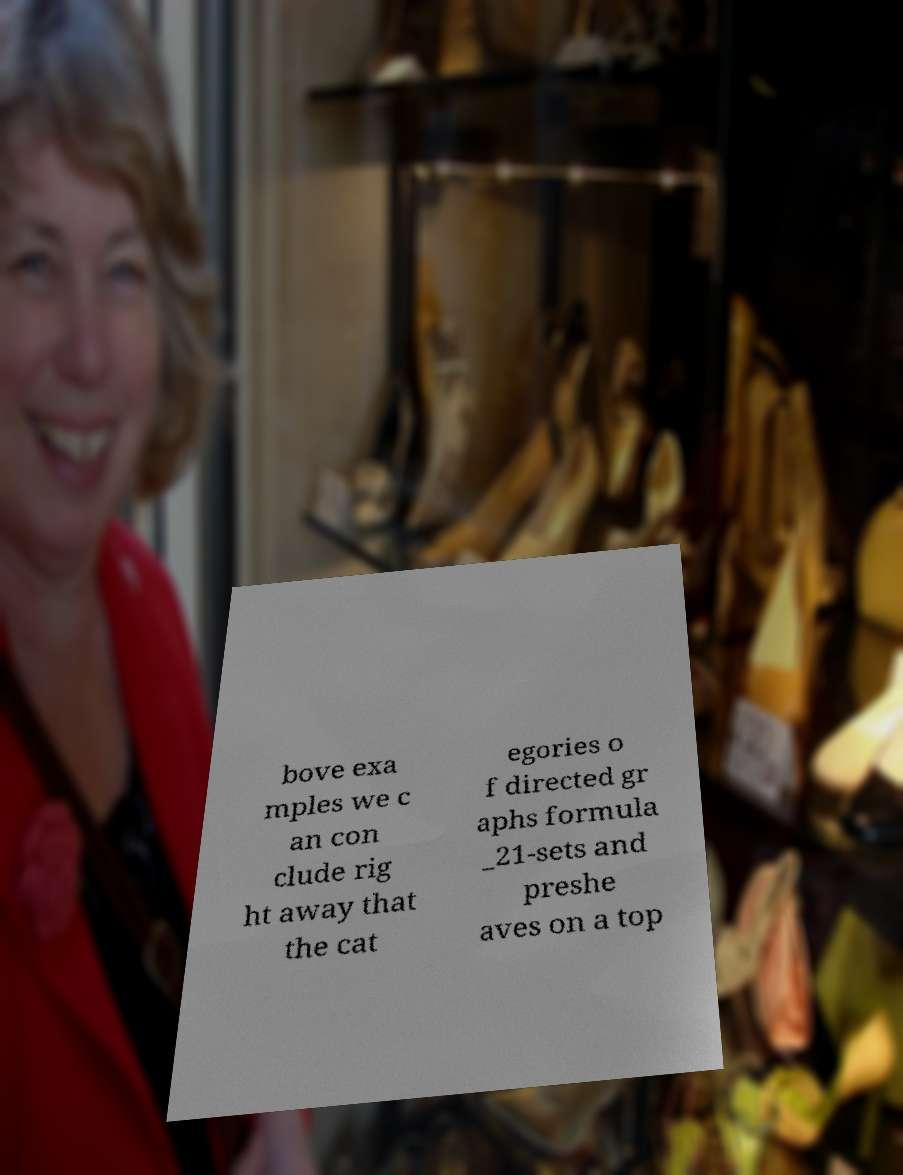There's text embedded in this image that I need extracted. Can you transcribe it verbatim? bove exa mples we c an con clude rig ht away that the cat egories o f directed gr aphs formula _21-sets and preshe aves on a top 